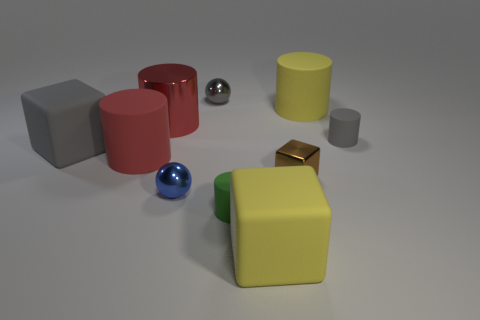What can you tell me about the arrangement of objects in this image? The objects are arranged on a flat surface, seemingly at random. There is a mixture of geometric shapes and various colors, suggesting an abstract or educational purpose, possibly related to a sorting or counting activity. 